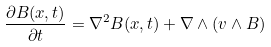<formula> <loc_0><loc_0><loc_500><loc_500>\frac { \partial { B } ( { x } , t ) } { \partial t } = \nabla ^ { 2 } { B } ( { x } , t ) + \nabla \wedge ( { v } \wedge { B } )</formula> 